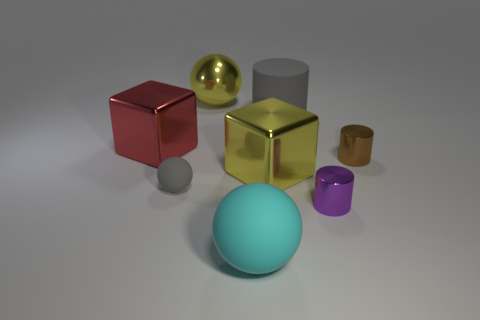How big is the metallic thing that is on the left side of the brown metal object and on the right side of the rubber cylinder? The metallic object to the left of the brown metal cube and to the right of the grey rubber cylinder appears to be a small golden cup. Its size is roughly comparable to that of a standard shot glass, significantly smaller in terms of height and diameter when compared to the other objects in the image. 